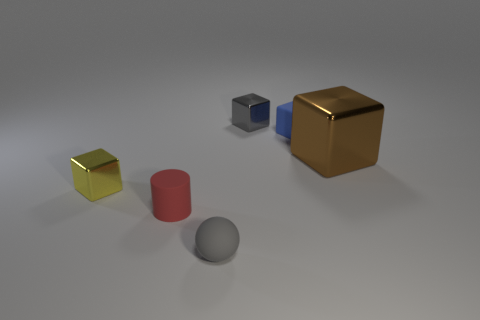What number of things are made of the same material as the large brown cube?
Make the answer very short. 2. What is the size of the gray metallic object that is the same shape as the small blue matte object?
Provide a succinct answer. Small. There is a red matte object; are there any tiny shiny cubes in front of it?
Provide a short and direct response. No. What is the material of the brown block?
Provide a short and direct response. Metal. Does the tiny shiny object to the right of the tiny yellow shiny object have the same color as the matte ball?
Provide a succinct answer. Yes. Are there any other things that have the same shape as the tiny red thing?
Ensure brevity in your answer.  No. There is another large metallic object that is the same shape as the yellow object; what is its color?
Provide a short and direct response. Brown. What is the material of the big cube that is behind the small gray rubber ball?
Ensure brevity in your answer.  Metal. What color is the cylinder?
Ensure brevity in your answer.  Red. There is a block to the left of the sphere; does it have the same size as the gray rubber sphere?
Keep it short and to the point. Yes. 